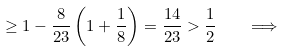Convert formula to latex. <formula><loc_0><loc_0><loc_500><loc_500>\geq 1 - \frac { 8 } { 2 3 } \left ( 1 + \frac { 1 } { 8 } \right ) = \frac { 1 4 } { 2 3 } > \frac { 1 } { 2 } \quad \Longrightarrow</formula> 